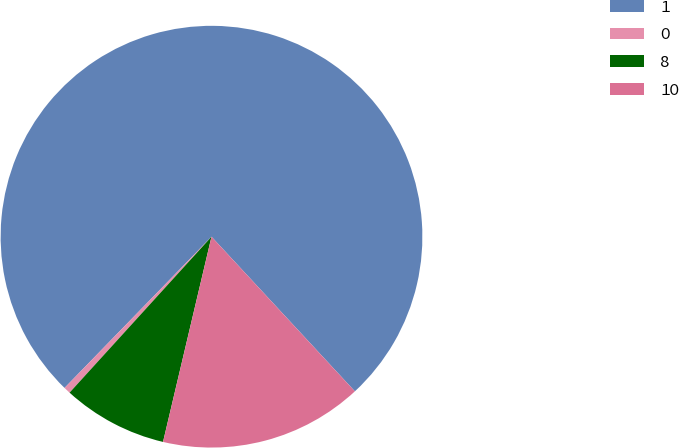Convert chart to OTSL. <chart><loc_0><loc_0><loc_500><loc_500><pie_chart><fcel>1<fcel>0<fcel>8<fcel>10<nl><fcel>75.83%<fcel>0.52%<fcel>8.06%<fcel>15.59%<nl></chart> 